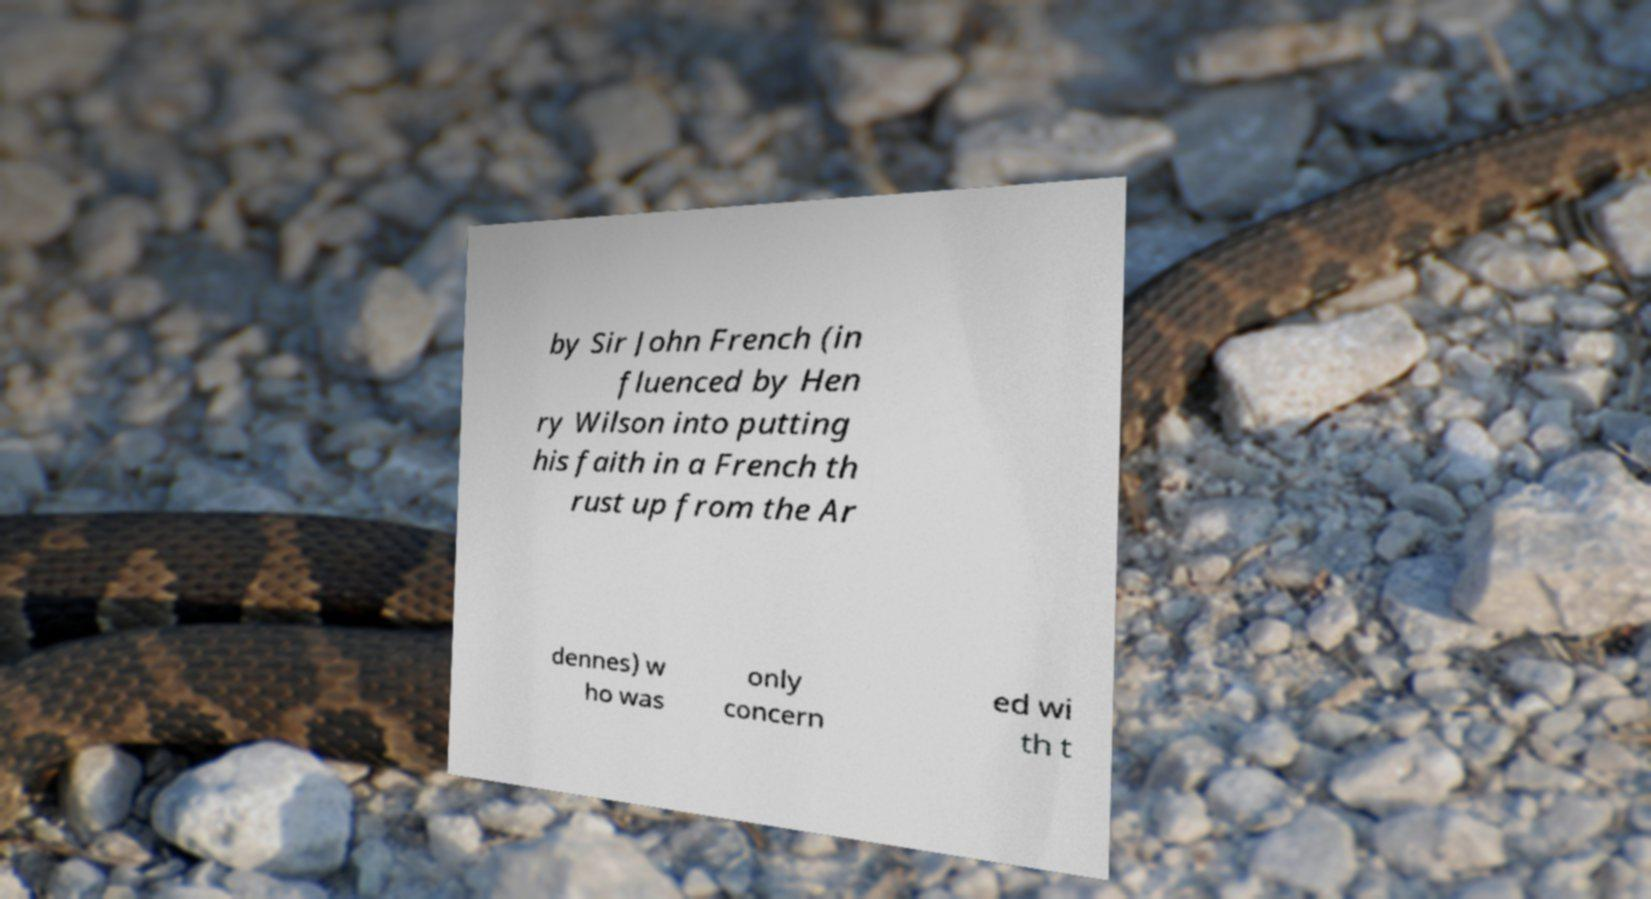Please read and relay the text visible in this image. What does it say? by Sir John French (in fluenced by Hen ry Wilson into putting his faith in a French th rust up from the Ar dennes) w ho was only concern ed wi th t 